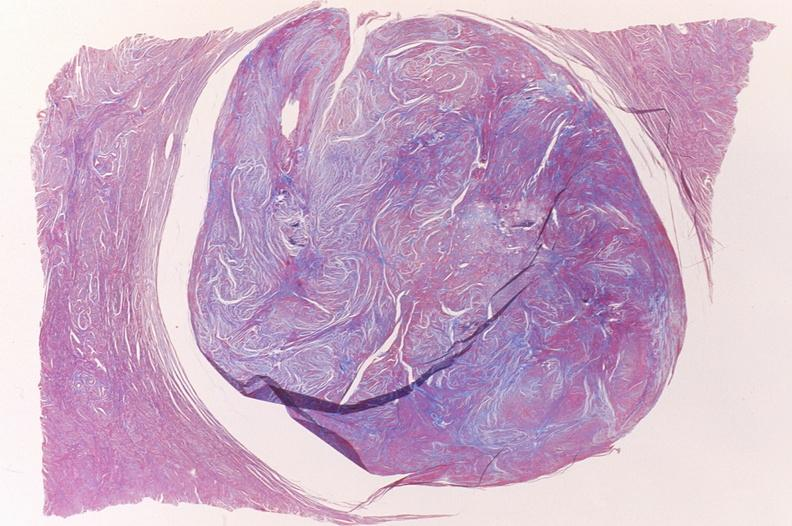does this image show leiomyoma, trichrome?
Answer the question using a single word or phrase. Yes 